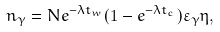Convert formula to latex. <formula><loc_0><loc_0><loc_500><loc_500>n _ { \gamma } = N e ^ { - \lambda t _ { w } } ( 1 - e ^ { - \lambda t _ { c } } ) \varepsilon _ { \gamma } \eta ,</formula> 